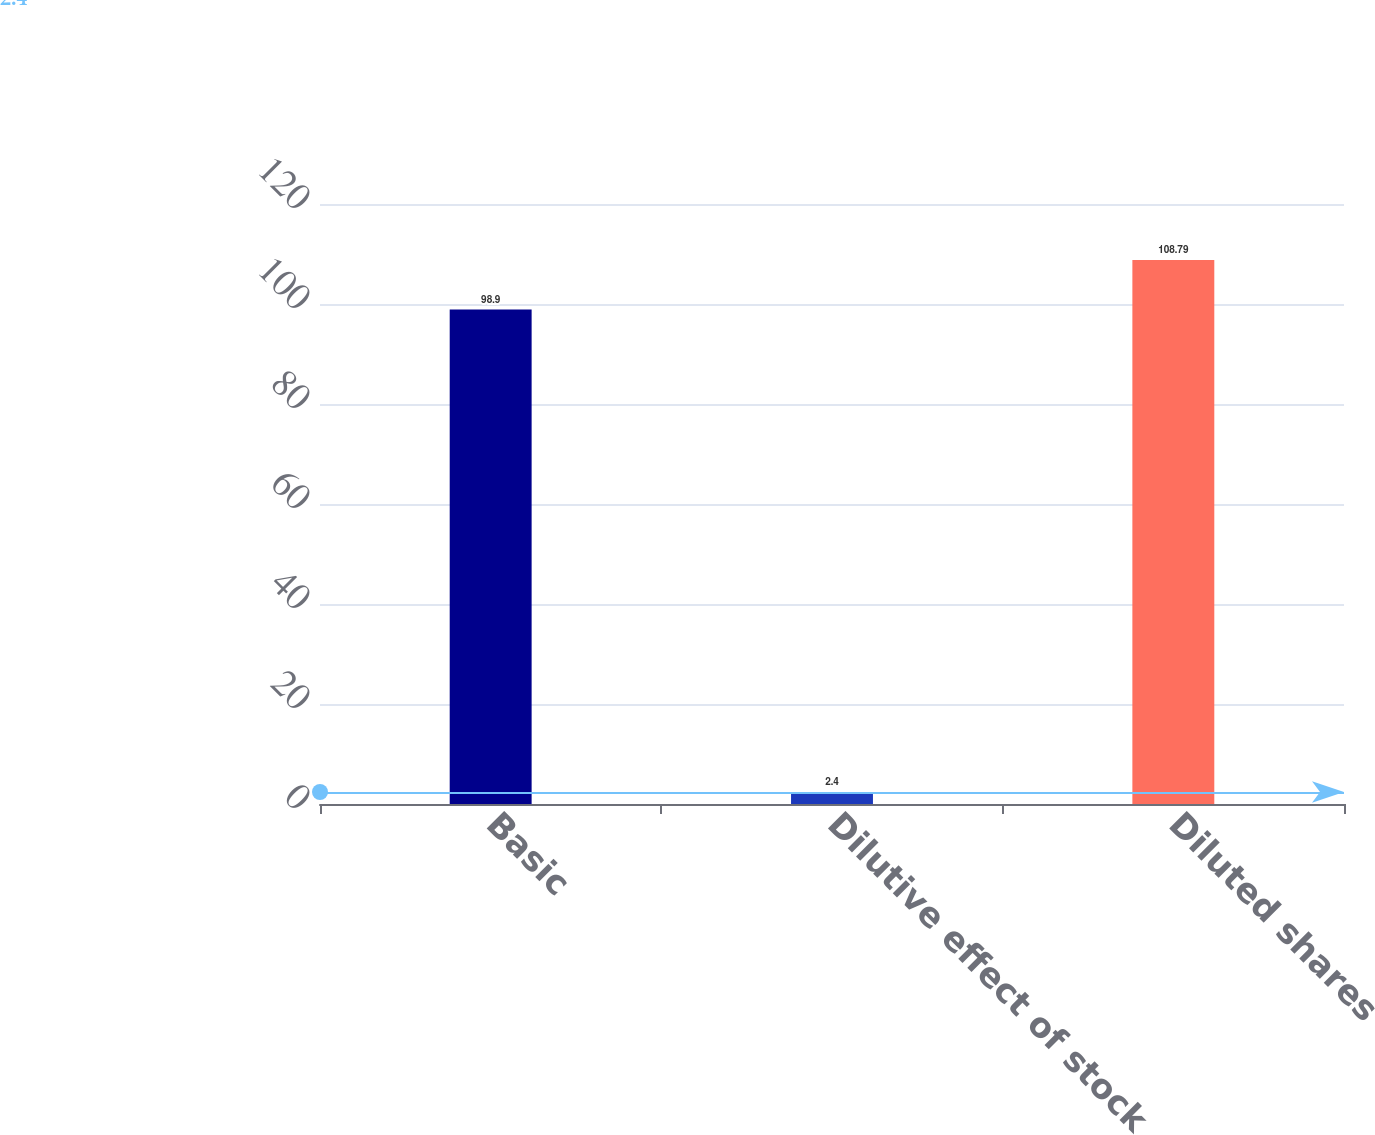Convert chart to OTSL. <chart><loc_0><loc_0><loc_500><loc_500><bar_chart><fcel>Basic<fcel>Dilutive effect of stock<fcel>Diluted shares<nl><fcel>98.9<fcel>2.4<fcel>108.79<nl></chart> 